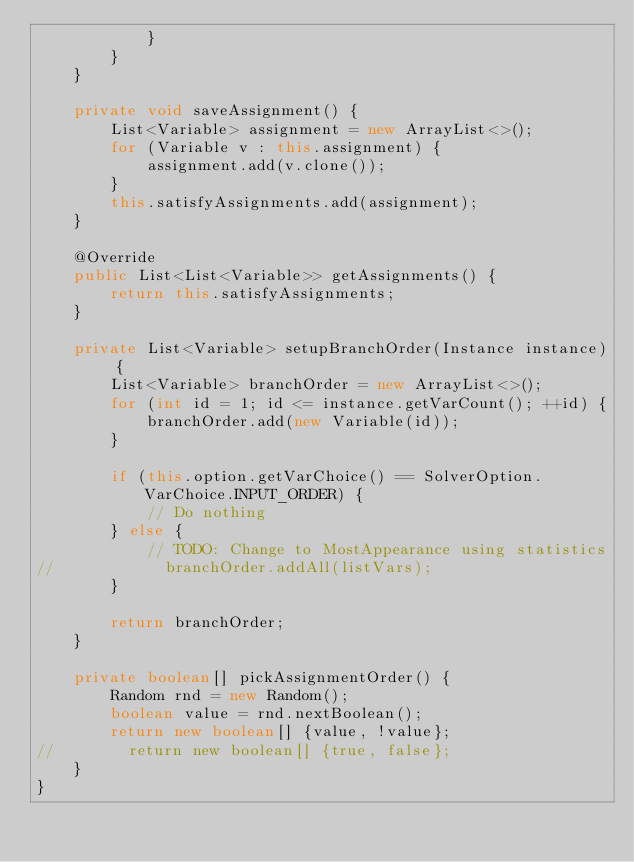Convert code to text. <code><loc_0><loc_0><loc_500><loc_500><_Java_>            }
        }
    }

    private void saveAssignment() {
        List<Variable> assignment = new ArrayList<>();
        for (Variable v : this.assignment) {
            assignment.add(v.clone());
        }
        this.satisfyAssignments.add(assignment);
    }

    @Override
    public List<List<Variable>> getAssignments() {
        return this.satisfyAssignments;
    }

    private List<Variable> setupBranchOrder(Instance instance) {
        List<Variable> branchOrder = new ArrayList<>();
        for (int id = 1; id <= instance.getVarCount(); ++id) {
            branchOrder.add(new Variable(id));
        }

        if (this.option.getVarChoice() == SolverOption.VarChoice.INPUT_ORDER) {
            // Do nothing
        } else {
            // TODO: Change to MostAppearance using statistics
//            branchOrder.addAll(listVars);
        }

        return branchOrder;
    }

    private boolean[] pickAssignmentOrder() {
        Random rnd = new Random();
        boolean value = rnd.nextBoolean();
        return new boolean[] {value, !value};
//        return new boolean[] {true, false};
    }
}
</code> 